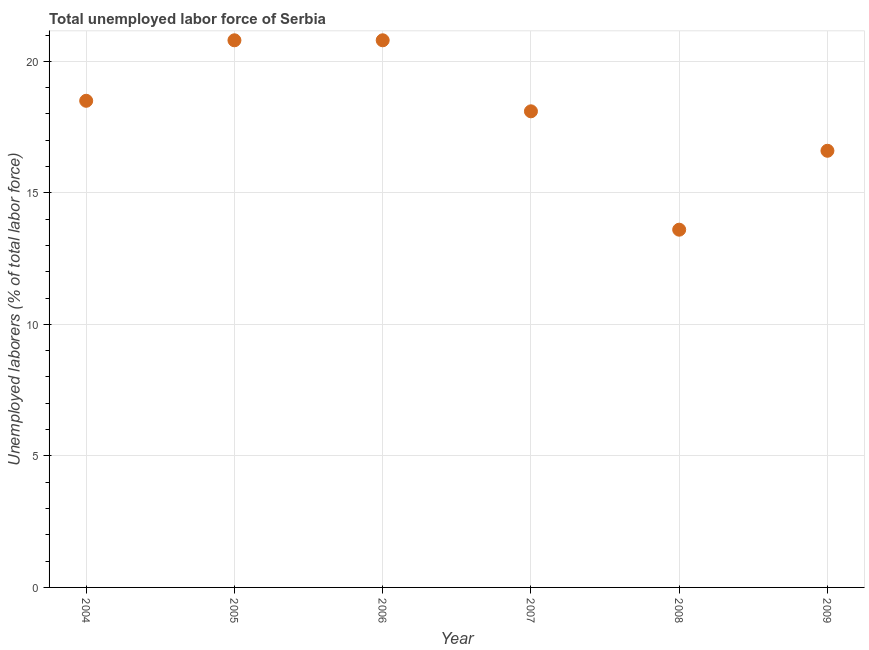What is the total unemployed labour force in 2008?
Offer a very short reply. 13.6. Across all years, what is the maximum total unemployed labour force?
Your response must be concise. 20.8. Across all years, what is the minimum total unemployed labour force?
Make the answer very short. 13.6. In which year was the total unemployed labour force maximum?
Make the answer very short. 2005. What is the sum of the total unemployed labour force?
Your answer should be very brief. 108.4. What is the difference between the total unemployed labour force in 2006 and 2007?
Ensure brevity in your answer.  2.7. What is the average total unemployed labour force per year?
Your response must be concise. 18.07. What is the median total unemployed labour force?
Provide a short and direct response. 18.3. What is the ratio of the total unemployed labour force in 2004 to that in 2007?
Your answer should be very brief. 1.02. Is the total unemployed labour force in 2006 less than that in 2008?
Offer a terse response. No. Is the difference between the total unemployed labour force in 2005 and 2008 greater than the difference between any two years?
Ensure brevity in your answer.  Yes. Is the sum of the total unemployed labour force in 2005 and 2007 greater than the maximum total unemployed labour force across all years?
Make the answer very short. Yes. What is the difference between the highest and the lowest total unemployed labour force?
Ensure brevity in your answer.  7.2. In how many years, is the total unemployed labour force greater than the average total unemployed labour force taken over all years?
Provide a succinct answer. 4. Does the total unemployed labour force monotonically increase over the years?
Give a very brief answer. No. How many years are there in the graph?
Give a very brief answer. 6. Are the values on the major ticks of Y-axis written in scientific E-notation?
Give a very brief answer. No. Does the graph contain grids?
Make the answer very short. Yes. What is the title of the graph?
Offer a very short reply. Total unemployed labor force of Serbia. What is the label or title of the Y-axis?
Give a very brief answer. Unemployed laborers (% of total labor force). What is the Unemployed laborers (% of total labor force) in 2004?
Provide a succinct answer. 18.5. What is the Unemployed laborers (% of total labor force) in 2005?
Provide a succinct answer. 20.8. What is the Unemployed laborers (% of total labor force) in 2006?
Provide a short and direct response. 20.8. What is the Unemployed laborers (% of total labor force) in 2007?
Make the answer very short. 18.1. What is the Unemployed laborers (% of total labor force) in 2008?
Make the answer very short. 13.6. What is the Unemployed laborers (% of total labor force) in 2009?
Provide a succinct answer. 16.6. What is the difference between the Unemployed laborers (% of total labor force) in 2004 and 2005?
Provide a short and direct response. -2.3. What is the difference between the Unemployed laborers (% of total labor force) in 2004 and 2006?
Provide a short and direct response. -2.3. What is the difference between the Unemployed laborers (% of total labor force) in 2004 and 2008?
Offer a terse response. 4.9. What is the difference between the Unemployed laborers (% of total labor force) in 2004 and 2009?
Make the answer very short. 1.9. What is the difference between the Unemployed laborers (% of total labor force) in 2006 and 2007?
Give a very brief answer. 2.7. What is the difference between the Unemployed laborers (% of total labor force) in 2006 and 2008?
Your answer should be very brief. 7.2. What is the difference between the Unemployed laborers (% of total labor force) in 2007 and 2009?
Provide a short and direct response. 1.5. What is the difference between the Unemployed laborers (% of total labor force) in 2008 and 2009?
Provide a short and direct response. -3. What is the ratio of the Unemployed laborers (% of total labor force) in 2004 to that in 2005?
Offer a terse response. 0.89. What is the ratio of the Unemployed laborers (% of total labor force) in 2004 to that in 2006?
Offer a terse response. 0.89. What is the ratio of the Unemployed laborers (% of total labor force) in 2004 to that in 2008?
Offer a very short reply. 1.36. What is the ratio of the Unemployed laborers (% of total labor force) in 2004 to that in 2009?
Provide a succinct answer. 1.11. What is the ratio of the Unemployed laborers (% of total labor force) in 2005 to that in 2007?
Your answer should be compact. 1.15. What is the ratio of the Unemployed laborers (% of total labor force) in 2005 to that in 2008?
Provide a short and direct response. 1.53. What is the ratio of the Unemployed laborers (% of total labor force) in 2005 to that in 2009?
Provide a succinct answer. 1.25. What is the ratio of the Unemployed laborers (% of total labor force) in 2006 to that in 2007?
Give a very brief answer. 1.15. What is the ratio of the Unemployed laborers (% of total labor force) in 2006 to that in 2008?
Offer a terse response. 1.53. What is the ratio of the Unemployed laborers (% of total labor force) in 2006 to that in 2009?
Provide a short and direct response. 1.25. What is the ratio of the Unemployed laborers (% of total labor force) in 2007 to that in 2008?
Offer a terse response. 1.33. What is the ratio of the Unemployed laborers (% of total labor force) in 2007 to that in 2009?
Your answer should be compact. 1.09. What is the ratio of the Unemployed laborers (% of total labor force) in 2008 to that in 2009?
Provide a succinct answer. 0.82. 